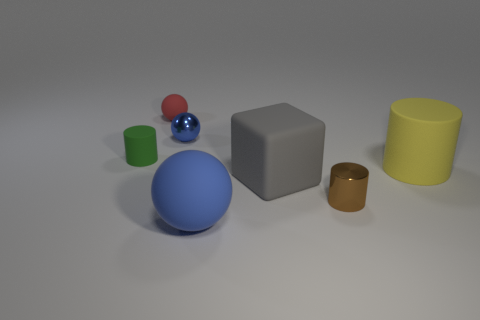Is the number of big matte cylinders that are left of the large blue ball the same as the number of large rubber spheres that are behind the green thing?
Offer a very short reply. Yes. What material is the blue ball to the right of the blue sphere behind the tiny brown metal thing?
Your response must be concise. Rubber. What number of things are small red matte things or small blue matte things?
Your response must be concise. 1. The matte thing that is the same color as the small shiny ball is what size?
Provide a succinct answer. Large. Are there fewer small cyan matte things than big rubber objects?
Keep it short and to the point. Yes. The green cylinder that is made of the same material as the gray object is what size?
Your response must be concise. Small. What size is the red rubber object?
Your answer should be very brief. Small. There is a gray matte thing; what shape is it?
Offer a very short reply. Cube. Do the tiny shiny thing that is right of the tiny blue ball and the big sphere have the same color?
Ensure brevity in your answer.  No. What is the size of the blue rubber object that is the same shape as the blue shiny thing?
Offer a very short reply. Large. 